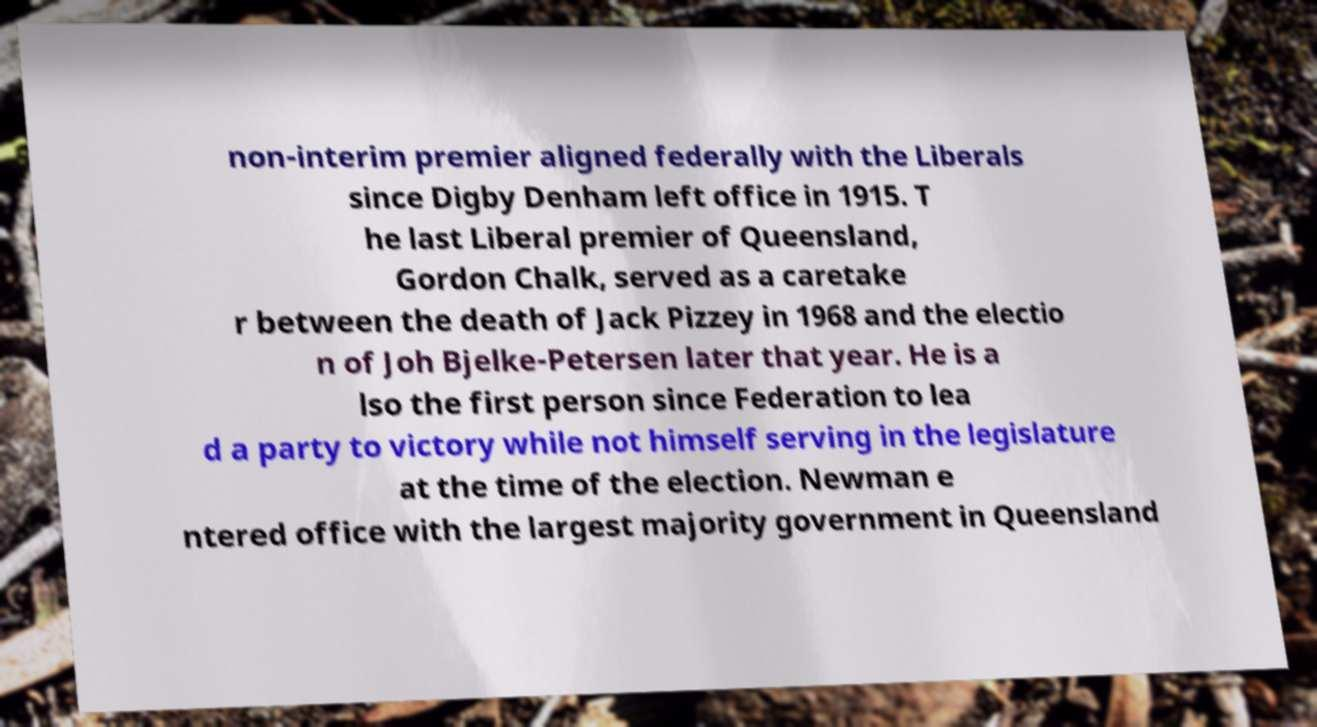Please identify and transcribe the text found in this image. non-interim premier aligned federally with the Liberals since Digby Denham left office in 1915. T he last Liberal premier of Queensland, Gordon Chalk, served as a caretake r between the death of Jack Pizzey in 1968 and the electio n of Joh Bjelke-Petersen later that year. He is a lso the first person since Federation to lea d a party to victory while not himself serving in the legislature at the time of the election. Newman e ntered office with the largest majority government in Queensland 